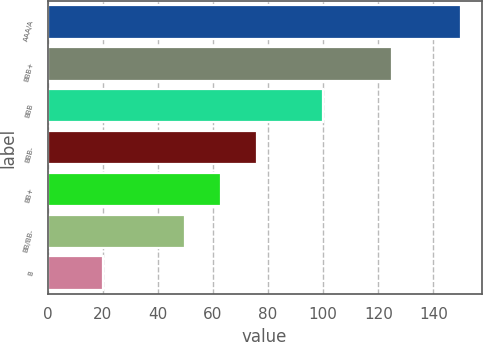Convert chart. <chart><loc_0><loc_0><loc_500><loc_500><bar_chart><fcel>AAA/A<fcel>BBB+<fcel>BBB<fcel>BBB-<fcel>BB+<fcel>BB/BB-<fcel>B<nl><fcel>150<fcel>125<fcel>100<fcel>76<fcel>63<fcel>50<fcel>20<nl></chart> 